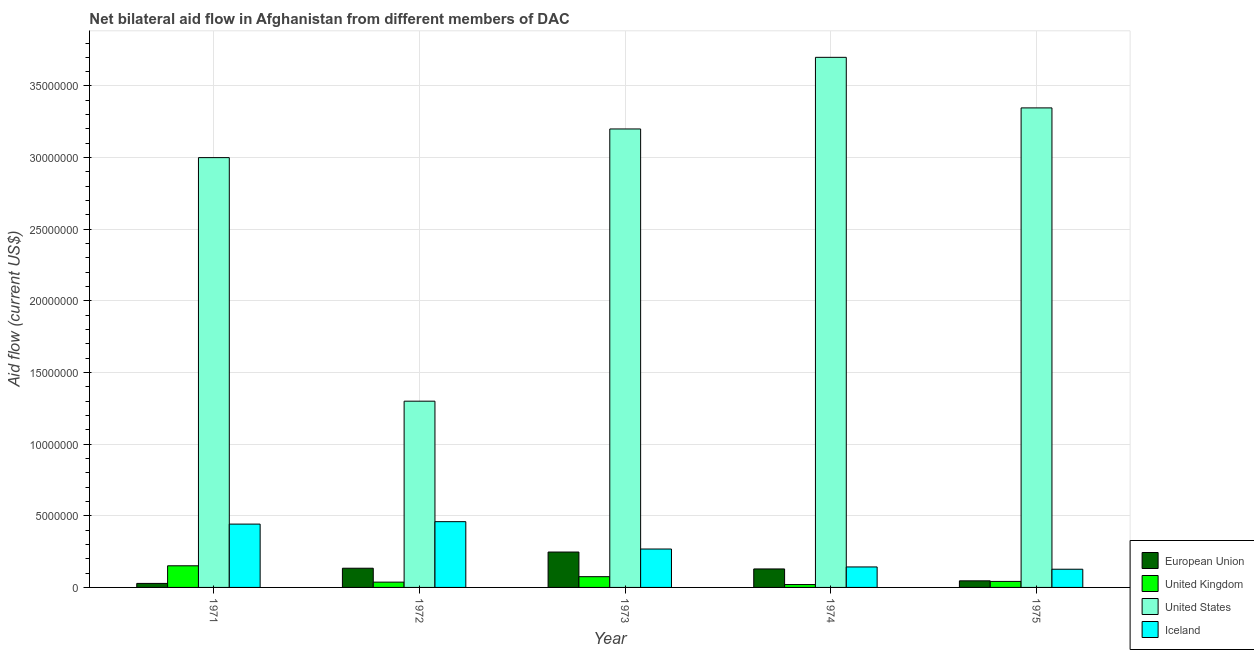How many different coloured bars are there?
Keep it short and to the point. 4. How many groups of bars are there?
Ensure brevity in your answer.  5. Are the number of bars per tick equal to the number of legend labels?
Your answer should be compact. Yes. How many bars are there on the 5th tick from the right?
Offer a very short reply. 4. What is the label of the 5th group of bars from the left?
Give a very brief answer. 1975. In how many cases, is the number of bars for a given year not equal to the number of legend labels?
Provide a short and direct response. 0. What is the amount of aid given by us in 1973?
Provide a succinct answer. 3.20e+07. Across all years, what is the maximum amount of aid given by us?
Your answer should be compact. 3.70e+07. Across all years, what is the minimum amount of aid given by iceland?
Offer a terse response. 1.27e+06. In which year was the amount of aid given by iceland maximum?
Provide a succinct answer. 1972. What is the total amount of aid given by us in the graph?
Provide a succinct answer. 1.45e+08. What is the difference between the amount of aid given by us in 1972 and that in 1975?
Your answer should be compact. -2.05e+07. What is the difference between the amount of aid given by uk in 1974 and the amount of aid given by eu in 1973?
Make the answer very short. -5.50e+05. What is the average amount of aid given by eu per year?
Offer a terse response. 1.17e+06. In the year 1974, what is the difference between the amount of aid given by uk and amount of aid given by eu?
Give a very brief answer. 0. What is the ratio of the amount of aid given by us in 1971 to that in 1975?
Your response must be concise. 0.9. Is the difference between the amount of aid given by us in 1971 and 1974 greater than the difference between the amount of aid given by iceland in 1971 and 1974?
Ensure brevity in your answer.  No. What is the difference between the highest and the second highest amount of aid given by eu?
Ensure brevity in your answer.  1.13e+06. What is the difference between the highest and the lowest amount of aid given by eu?
Make the answer very short. 2.19e+06. In how many years, is the amount of aid given by iceland greater than the average amount of aid given by iceland taken over all years?
Provide a succinct answer. 2. Is it the case that in every year, the sum of the amount of aid given by us and amount of aid given by uk is greater than the sum of amount of aid given by iceland and amount of aid given by eu?
Your answer should be compact. No. What does the 1st bar from the right in 1971 represents?
Ensure brevity in your answer.  Iceland. Is it the case that in every year, the sum of the amount of aid given by eu and amount of aid given by uk is greater than the amount of aid given by us?
Provide a succinct answer. No. How many bars are there?
Ensure brevity in your answer.  20. Are all the bars in the graph horizontal?
Provide a short and direct response. No. Are the values on the major ticks of Y-axis written in scientific E-notation?
Give a very brief answer. No. Does the graph contain any zero values?
Your answer should be very brief. No. Where does the legend appear in the graph?
Give a very brief answer. Bottom right. How many legend labels are there?
Make the answer very short. 4. What is the title of the graph?
Ensure brevity in your answer.  Net bilateral aid flow in Afghanistan from different members of DAC. Does "Subsidies and Transfers" appear as one of the legend labels in the graph?
Ensure brevity in your answer.  No. What is the label or title of the X-axis?
Keep it short and to the point. Year. What is the label or title of the Y-axis?
Give a very brief answer. Aid flow (current US$). What is the Aid flow (current US$) in European Union in 1971?
Your answer should be compact. 2.80e+05. What is the Aid flow (current US$) of United Kingdom in 1971?
Give a very brief answer. 1.51e+06. What is the Aid flow (current US$) of United States in 1971?
Keep it short and to the point. 3.00e+07. What is the Aid flow (current US$) of Iceland in 1971?
Provide a short and direct response. 4.42e+06. What is the Aid flow (current US$) of European Union in 1972?
Offer a terse response. 1.34e+06. What is the Aid flow (current US$) of United States in 1972?
Make the answer very short. 1.30e+07. What is the Aid flow (current US$) in Iceland in 1972?
Your answer should be compact. 4.59e+06. What is the Aid flow (current US$) of European Union in 1973?
Offer a terse response. 2.47e+06. What is the Aid flow (current US$) of United Kingdom in 1973?
Provide a succinct answer. 7.50e+05. What is the Aid flow (current US$) in United States in 1973?
Make the answer very short. 3.20e+07. What is the Aid flow (current US$) of Iceland in 1973?
Ensure brevity in your answer.  2.68e+06. What is the Aid flow (current US$) in European Union in 1974?
Provide a short and direct response. 1.29e+06. What is the Aid flow (current US$) in United States in 1974?
Provide a succinct answer. 3.70e+07. What is the Aid flow (current US$) in Iceland in 1974?
Your response must be concise. 1.43e+06. What is the Aid flow (current US$) of European Union in 1975?
Offer a very short reply. 4.60e+05. What is the Aid flow (current US$) in United States in 1975?
Your response must be concise. 3.35e+07. What is the Aid flow (current US$) in Iceland in 1975?
Make the answer very short. 1.27e+06. Across all years, what is the maximum Aid flow (current US$) in European Union?
Your response must be concise. 2.47e+06. Across all years, what is the maximum Aid flow (current US$) in United Kingdom?
Provide a short and direct response. 1.51e+06. Across all years, what is the maximum Aid flow (current US$) in United States?
Your answer should be very brief. 3.70e+07. Across all years, what is the maximum Aid flow (current US$) of Iceland?
Keep it short and to the point. 4.59e+06. Across all years, what is the minimum Aid flow (current US$) in United States?
Make the answer very short. 1.30e+07. Across all years, what is the minimum Aid flow (current US$) in Iceland?
Ensure brevity in your answer.  1.27e+06. What is the total Aid flow (current US$) of European Union in the graph?
Keep it short and to the point. 5.84e+06. What is the total Aid flow (current US$) in United Kingdom in the graph?
Offer a terse response. 3.25e+06. What is the total Aid flow (current US$) of United States in the graph?
Keep it short and to the point. 1.45e+08. What is the total Aid flow (current US$) of Iceland in the graph?
Make the answer very short. 1.44e+07. What is the difference between the Aid flow (current US$) in European Union in 1971 and that in 1972?
Your answer should be compact. -1.06e+06. What is the difference between the Aid flow (current US$) of United Kingdom in 1971 and that in 1972?
Offer a very short reply. 1.14e+06. What is the difference between the Aid flow (current US$) of United States in 1971 and that in 1972?
Ensure brevity in your answer.  1.70e+07. What is the difference between the Aid flow (current US$) in European Union in 1971 and that in 1973?
Your response must be concise. -2.19e+06. What is the difference between the Aid flow (current US$) in United Kingdom in 1971 and that in 1973?
Ensure brevity in your answer.  7.60e+05. What is the difference between the Aid flow (current US$) of Iceland in 1971 and that in 1973?
Offer a very short reply. 1.74e+06. What is the difference between the Aid flow (current US$) in European Union in 1971 and that in 1974?
Your answer should be very brief. -1.01e+06. What is the difference between the Aid flow (current US$) of United Kingdom in 1971 and that in 1974?
Your answer should be compact. 1.31e+06. What is the difference between the Aid flow (current US$) in United States in 1971 and that in 1974?
Offer a terse response. -7.00e+06. What is the difference between the Aid flow (current US$) in Iceland in 1971 and that in 1974?
Provide a succinct answer. 2.99e+06. What is the difference between the Aid flow (current US$) in European Union in 1971 and that in 1975?
Ensure brevity in your answer.  -1.80e+05. What is the difference between the Aid flow (current US$) in United Kingdom in 1971 and that in 1975?
Your response must be concise. 1.09e+06. What is the difference between the Aid flow (current US$) in United States in 1971 and that in 1975?
Your response must be concise. -3.47e+06. What is the difference between the Aid flow (current US$) of Iceland in 1971 and that in 1975?
Your answer should be very brief. 3.15e+06. What is the difference between the Aid flow (current US$) of European Union in 1972 and that in 1973?
Your answer should be very brief. -1.13e+06. What is the difference between the Aid flow (current US$) of United Kingdom in 1972 and that in 1973?
Provide a short and direct response. -3.80e+05. What is the difference between the Aid flow (current US$) of United States in 1972 and that in 1973?
Offer a very short reply. -1.90e+07. What is the difference between the Aid flow (current US$) in Iceland in 1972 and that in 1973?
Give a very brief answer. 1.91e+06. What is the difference between the Aid flow (current US$) in United States in 1972 and that in 1974?
Make the answer very short. -2.40e+07. What is the difference between the Aid flow (current US$) of Iceland in 1972 and that in 1974?
Ensure brevity in your answer.  3.16e+06. What is the difference between the Aid flow (current US$) of European Union in 1972 and that in 1975?
Your response must be concise. 8.80e+05. What is the difference between the Aid flow (current US$) in United States in 1972 and that in 1975?
Your answer should be compact. -2.05e+07. What is the difference between the Aid flow (current US$) in Iceland in 1972 and that in 1975?
Provide a succinct answer. 3.32e+06. What is the difference between the Aid flow (current US$) of European Union in 1973 and that in 1974?
Offer a terse response. 1.18e+06. What is the difference between the Aid flow (current US$) of United States in 1973 and that in 1974?
Ensure brevity in your answer.  -5.00e+06. What is the difference between the Aid flow (current US$) in Iceland in 1973 and that in 1974?
Your response must be concise. 1.25e+06. What is the difference between the Aid flow (current US$) in European Union in 1973 and that in 1975?
Your answer should be compact. 2.01e+06. What is the difference between the Aid flow (current US$) of United States in 1973 and that in 1975?
Your answer should be very brief. -1.47e+06. What is the difference between the Aid flow (current US$) of Iceland in 1973 and that in 1975?
Give a very brief answer. 1.41e+06. What is the difference between the Aid flow (current US$) in European Union in 1974 and that in 1975?
Keep it short and to the point. 8.30e+05. What is the difference between the Aid flow (current US$) in United States in 1974 and that in 1975?
Your answer should be compact. 3.53e+06. What is the difference between the Aid flow (current US$) of European Union in 1971 and the Aid flow (current US$) of United States in 1972?
Provide a short and direct response. -1.27e+07. What is the difference between the Aid flow (current US$) in European Union in 1971 and the Aid flow (current US$) in Iceland in 1972?
Your answer should be compact. -4.31e+06. What is the difference between the Aid flow (current US$) in United Kingdom in 1971 and the Aid flow (current US$) in United States in 1972?
Give a very brief answer. -1.15e+07. What is the difference between the Aid flow (current US$) of United Kingdom in 1971 and the Aid flow (current US$) of Iceland in 1972?
Offer a terse response. -3.08e+06. What is the difference between the Aid flow (current US$) in United States in 1971 and the Aid flow (current US$) in Iceland in 1972?
Offer a terse response. 2.54e+07. What is the difference between the Aid flow (current US$) of European Union in 1971 and the Aid flow (current US$) of United Kingdom in 1973?
Offer a very short reply. -4.70e+05. What is the difference between the Aid flow (current US$) in European Union in 1971 and the Aid flow (current US$) in United States in 1973?
Make the answer very short. -3.17e+07. What is the difference between the Aid flow (current US$) in European Union in 1971 and the Aid flow (current US$) in Iceland in 1973?
Ensure brevity in your answer.  -2.40e+06. What is the difference between the Aid flow (current US$) in United Kingdom in 1971 and the Aid flow (current US$) in United States in 1973?
Your answer should be very brief. -3.05e+07. What is the difference between the Aid flow (current US$) of United Kingdom in 1971 and the Aid flow (current US$) of Iceland in 1973?
Provide a short and direct response. -1.17e+06. What is the difference between the Aid flow (current US$) of United States in 1971 and the Aid flow (current US$) of Iceland in 1973?
Give a very brief answer. 2.73e+07. What is the difference between the Aid flow (current US$) in European Union in 1971 and the Aid flow (current US$) in United Kingdom in 1974?
Make the answer very short. 8.00e+04. What is the difference between the Aid flow (current US$) in European Union in 1971 and the Aid flow (current US$) in United States in 1974?
Your response must be concise. -3.67e+07. What is the difference between the Aid flow (current US$) in European Union in 1971 and the Aid flow (current US$) in Iceland in 1974?
Provide a succinct answer. -1.15e+06. What is the difference between the Aid flow (current US$) in United Kingdom in 1971 and the Aid flow (current US$) in United States in 1974?
Keep it short and to the point. -3.55e+07. What is the difference between the Aid flow (current US$) of United Kingdom in 1971 and the Aid flow (current US$) of Iceland in 1974?
Keep it short and to the point. 8.00e+04. What is the difference between the Aid flow (current US$) of United States in 1971 and the Aid flow (current US$) of Iceland in 1974?
Offer a very short reply. 2.86e+07. What is the difference between the Aid flow (current US$) of European Union in 1971 and the Aid flow (current US$) of United States in 1975?
Make the answer very short. -3.32e+07. What is the difference between the Aid flow (current US$) of European Union in 1971 and the Aid flow (current US$) of Iceland in 1975?
Offer a terse response. -9.90e+05. What is the difference between the Aid flow (current US$) of United Kingdom in 1971 and the Aid flow (current US$) of United States in 1975?
Ensure brevity in your answer.  -3.20e+07. What is the difference between the Aid flow (current US$) of United States in 1971 and the Aid flow (current US$) of Iceland in 1975?
Give a very brief answer. 2.87e+07. What is the difference between the Aid flow (current US$) of European Union in 1972 and the Aid flow (current US$) of United Kingdom in 1973?
Provide a succinct answer. 5.90e+05. What is the difference between the Aid flow (current US$) of European Union in 1972 and the Aid flow (current US$) of United States in 1973?
Your answer should be very brief. -3.07e+07. What is the difference between the Aid flow (current US$) of European Union in 1972 and the Aid flow (current US$) of Iceland in 1973?
Make the answer very short. -1.34e+06. What is the difference between the Aid flow (current US$) of United Kingdom in 1972 and the Aid flow (current US$) of United States in 1973?
Make the answer very short. -3.16e+07. What is the difference between the Aid flow (current US$) in United Kingdom in 1972 and the Aid flow (current US$) in Iceland in 1973?
Ensure brevity in your answer.  -2.31e+06. What is the difference between the Aid flow (current US$) of United States in 1972 and the Aid flow (current US$) of Iceland in 1973?
Your response must be concise. 1.03e+07. What is the difference between the Aid flow (current US$) in European Union in 1972 and the Aid flow (current US$) in United Kingdom in 1974?
Your response must be concise. 1.14e+06. What is the difference between the Aid flow (current US$) of European Union in 1972 and the Aid flow (current US$) of United States in 1974?
Ensure brevity in your answer.  -3.57e+07. What is the difference between the Aid flow (current US$) of European Union in 1972 and the Aid flow (current US$) of Iceland in 1974?
Provide a short and direct response. -9.00e+04. What is the difference between the Aid flow (current US$) of United Kingdom in 1972 and the Aid flow (current US$) of United States in 1974?
Ensure brevity in your answer.  -3.66e+07. What is the difference between the Aid flow (current US$) in United Kingdom in 1972 and the Aid flow (current US$) in Iceland in 1974?
Your answer should be compact. -1.06e+06. What is the difference between the Aid flow (current US$) in United States in 1972 and the Aid flow (current US$) in Iceland in 1974?
Provide a succinct answer. 1.16e+07. What is the difference between the Aid flow (current US$) of European Union in 1972 and the Aid flow (current US$) of United Kingdom in 1975?
Your answer should be very brief. 9.20e+05. What is the difference between the Aid flow (current US$) in European Union in 1972 and the Aid flow (current US$) in United States in 1975?
Offer a very short reply. -3.21e+07. What is the difference between the Aid flow (current US$) in European Union in 1972 and the Aid flow (current US$) in Iceland in 1975?
Provide a succinct answer. 7.00e+04. What is the difference between the Aid flow (current US$) of United Kingdom in 1972 and the Aid flow (current US$) of United States in 1975?
Provide a short and direct response. -3.31e+07. What is the difference between the Aid flow (current US$) of United Kingdom in 1972 and the Aid flow (current US$) of Iceland in 1975?
Make the answer very short. -9.00e+05. What is the difference between the Aid flow (current US$) of United States in 1972 and the Aid flow (current US$) of Iceland in 1975?
Make the answer very short. 1.17e+07. What is the difference between the Aid flow (current US$) of European Union in 1973 and the Aid flow (current US$) of United Kingdom in 1974?
Your answer should be very brief. 2.27e+06. What is the difference between the Aid flow (current US$) of European Union in 1973 and the Aid flow (current US$) of United States in 1974?
Your response must be concise. -3.45e+07. What is the difference between the Aid flow (current US$) of European Union in 1973 and the Aid flow (current US$) of Iceland in 1974?
Your response must be concise. 1.04e+06. What is the difference between the Aid flow (current US$) of United Kingdom in 1973 and the Aid flow (current US$) of United States in 1974?
Provide a short and direct response. -3.62e+07. What is the difference between the Aid flow (current US$) in United Kingdom in 1973 and the Aid flow (current US$) in Iceland in 1974?
Provide a short and direct response. -6.80e+05. What is the difference between the Aid flow (current US$) in United States in 1973 and the Aid flow (current US$) in Iceland in 1974?
Offer a very short reply. 3.06e+07. What is the difference between the Aid flow (current US$) of European Union in 1973 and the Aid flow (current US$) of United Kingdom in 1975?
Provide a short and direct response. 2.05e+06. What is the difference between the Aid flow (current US$) of European Union in 1973 and the Aid flow (current US$) of United States in 1975?
Make the answer very short. -3.10e+07. What is the difference between the Aid flow (current US$) of European Union in 1973 and the Aid flow (current US$) of Iceland in 1975?
Make the answer very short. 1.20e+06. What is the difference between the Aid flow (current US$) in United Kingdom in 1973 and the Aid flow (current US$) in United States in 1975?
Offer a terse response. -3.27e+07. What is the difference between the Aid flow (current US$) in United Kingdom in 1973 and the Aid flow (current US$) in Iceland in 1975?
Offer a terse response. -5.20e+05. What is the difference between the Aid flow (current US$) of United States in 1973 and the Aid flow (current US$) of Iceland in 1975?
Provide a succinct answer. 3.07e+07. What is the difference between the Aid flow (current US$) of European Union in 1974 and the Aid flow (current US$) of United Kingdom in 1975?
Provide a succinct answer. 8.70e+05. What is the difference between the Aid flow (current US$) in European Union in 1974 and the Aid flow (current US$) in United States in 1975?
Your response must be concise. -3.22e+07. What is the difference between the Aid flow (current US$) in European Union in 1974 and the Aid flow (current US$) in Iceland in 1975?
Make the answer very short. 2.00e+04. What is the difference between the Aid flow (current US$) in United Kingdom in 1974 and the Aid flow (current US$) in United States in 1975?
Keep it short and to the point. -3.33e+07. What is the difference between the Aid flow (current US$) of United Kingdom in 1974 and the Aid flow (current US$) of Iceland in 1975?
Keep it short and to the point. -1.07e+06. What is the difference between the Aid flow (current US$) of United States in 1974 and the Aid flow (current US$) of Iceland in 1975?
Your answer should be compact. 3.57e+07. What is the average Aid flow (current US$) in European Union per year?
Your response must be concise. 1.17e+06. What is the average Aid flow (current US$) in United Kingdom per year?
Your response must be concise. 6.50e+05. What is the average Aid flow (current US$) in United States per year?
Offer a terse response. 2.91e+07. What is the average Aid flow (current US$) of Iceland per year?
Give a very brief answer. 2.88e+06. In the year 1971, what is the difference between the Aid flow (current US$) of European Union and Aid flow (current US$) of United Kingdom?
Make the answer very short. -1.23e+06. In the year 1971, what is the difference between the Aid flow (current US$) of European Union and Aid flow (current US$) of United States?
Offer a terse response. -2.97e+07. In the year 1971, what is the difference between the Aid flow (current US$) in European Union and Aid flow (current US$) in Iceland?
Offer a terse response. -4.14e+06. In the year 1971, what is the difference between the Aid flow (current US$) of United Kingdom and Aid flow (current US$) of United States?
Offer a very short reply. -2.85e+07. In the year 1971, what is the difference between the Aid flow (current US$) in United Kingdom and Aid flow (current US$) in Iceland?
Your answer should be compact. -2.91e+06. In the year 1971, what is the difference between the Aid flow (current US$) in United States and Aid flow (current US$) in Iceland?
Your response must be concise. 2.56e+07. In the year 1972, what is the difference between the Aid flow (current US$) of European Union and Aid flow (current US$) of United Kingdom?
Offer a very short reply. 9.70e+05. In the year 1972, what is the difference between the Aid flow (current US$) of European Union and Aid flow (current US$) of United States?
Your answer should be compact. -1.17e+07. In the year 1972, what is the difference between the Aid flow (current US$) of European Union and Aid flow (current US$) of Iceland?
Your answer should be compact. -3.25e+06. In the year 1972, what is the difference between the Aid flow (current US$) in United Kingdom and Aid flow (current US$) in United States?
Provide a succinct answer. -1.26e+07. In the year 1972, what is the difference between the Aid flow (current US$) of United Kingdom and Aid flow (current US$) of Iceland?
Provide a succinct answer. -4.22e+06. In the year 1972, what is the difference between the Aid flow (current US$) of United States and Aid flow (current US$) of Iceland?
Keep it short and to the point. 8.41e+06. In the year 1973, what is the difference between the Aid flow (current US$) of European Union and Aid flow (current US$) of United Kingdom?
Your answer should be very brief. 1.72e+06. In the year 1973, what is the difference between the Aid flow (current US$) of European Union and Aid flow (current US$) of United States?
Provide a succinct answer. -2.95e+07. In the year 1973, what is the difference between the Aid flow (current US$) of European Union and Aid flow (current US$) of Iceland?
Give a very brief answer. -2.10e+05. In the year 1973, what is the difference between the Aid flow (current US$) of United Kingdom and Aid flow (current US$) of United States?
Offer a terse response. -3.12e+07. In the year 1973, what is the difference between the Aid flow (current US$) of United Kingdom and Aid flow (current US$) of Iceland?
Ensure brevity in your answer.  -1.93e+06. In the year 1973, what is the difference between the Aid flow (current US$) in United States and Aid flow (current US$) in Iceland?
Make the answer very short. 2.93e+07. In the year 1974, what is the difference between the Aid flow (current US$) of European Union and Aid flow (current US$) of United Kingdom?
Provide a succinct answer. 1.09e+06. In the year 1974, what is the difference between the Aid flow (current US$) of European Union and Aid flow (current US$) of United States?
Ensure brevity in your answer.  -3.57e+07. In the year 1974, what is the difference between the Aid flow (current US$) of United Kingdom and Aid flow (current US$) of United States?
Keep it short and to the point. -3.68e+07. In the year 1974, what is the difference between the Aid flow (current US$) of United Kingdom and Aid flow (current US$) of Iceland?
Make the answer very short. -1.23e+06. In the year 1974, what is the difference between the Aid flow (current US$) of United States and Aid flow (current US$) of Iceland?
Offer a very short reply. 3.56e+07. In the year 1975, what is the difference between the Aid flow (current US$) of European Union and Aid flow (current US$) of United Kingdom?
Your answer should be compact. 4.00e+04. In the year 1975, what is the difference between the Aid flow (current US$) of European Union and Aid flow (current US$) of United States?
Give a very brief answer. -3.30e+07. In the year 1975, what is the difference between the Aid flow (current US$) in European Union and Aid flow (current US$) in Iceland?
Provide a succinct answer. -8.10e+05. In the year 1975, what is the difference between the Aid flow (current US$) in United Kingdom and Aid flow (current US$) in United States?
Provide a succinct answer. -3.30e+07. In the year 1975, what is the difference between the Aid flow (current US$) in United Kingdom and Aid flow (current US$) in Iceland?
Provide a succinct answer. -8.50e+05. In the year 1975, what is the difference between the Aid flow (current US$) of United States and Aid flow (current US$) of Iceland?
Provide a short and direct response. 3.22e+07. What is the ratio of the Aid flow (current US$) of European Union in 1971 to that in 1972?
Your answer should be very brief. 0.21. What is the ratio of the Aid flow (current US$) of United Kingdom in 1971 to that in 1972?
Your answer should be very brief. 4.08. What is the ratio of the Aid flow (current US$) in United States in 1971 to that in 1972?
Give a very brief answer. 2.31. What is the ratio of the Aid flow (current US$) of Iceland in 1971 to that in 1972?
Make the answer very short. 0.96. What is the ratio of the Aid flow (current US$) of European Union in 1971 to that in 1973?
Offer a terse response. 0.11. What is the ratio of the Aid flow (current US$) in United Kingdom in 1971 to that in 1973?
Keep it short and to the point. 2.01. What is the ratio of the Aid flow (current US$) of Iceland in 1971 to that in 1973?
Offer a very short reply. 1.65. What is the ratio of the Aid flow (current US$) in European Union in 1971 to that in 1974?
Your answer should be compact. 0.22. What is the ratio of the Aid flow (current US$) in United Kingdom in 1971 to that in 1974?
Provide a succinct answer. 7.55. What is the ratio of the Aid flow (current US$) in United States in 1971 to that in 1974?
Keep it short and to the point. 0.81. What is the ratio of the Aid flow (current US$) in Iceland in 1971 to that in 1974?
Provide a succinct answer. 3.09. What is the ratio of the Aid flow (current US$) of European Union in 1971 to that in 1975?
Offer a terse response. 0.61. What is the ratio of the Aid flow (current US$) of United Kingdom in 1971 to that in 1975?
Your answer should be compact. 3.6. What is the ratio of the Aid flow (current US$) of United States in 1971 to that in 1975?
Offer a very short reply. 0.9. What is the ratio of the Aid flow (current US$) in Iceland in 1971 to that in 1975?
Your answer should be very brief. 3.48. What is the ratio of the Aid flow (current US$) of European Union in 1972 to that in 1973?
Provide a short and direct response. 0.54. What is the ratio of the Aid flow (current US$) in United Kingdom in 1972 to that in 1973?
Ensure brevity in your answer.  0.49. What is the ratio of the Aid flow (current US$) in United States in 1972 to that in 1973?
Your response must be concise. 0.41. What is the ratio of the Aid flow (current US$) of Iceland in 1972 to that in 1973?
Your response must be concise. 1.71. What is the ratio of the Aid flow (current US$) in European Union in 1972 to that in 1974?
Ensure brevity in your answer.  1.04. What is the ratio of the Aid flow (current US$) of United Kingdom in 1972 to that in 1974?
Keep it short and to the point. 1.85. What is the ratio of the Aid flow (current US$) of United States in 1972 to that in 1974?
Give a very brief answer. 0.35. What is the ratio of the Aid flow (current US$) of Iceland in 1972 to that in 1974?
Your answer should be compact. 3.21. What is the ratio of the Aid flow (current US$) in European Union in 1972 to that in 1975?
Provide a short and direct response. 2.91. What is the ratio of the Aid flow (current US$) in United Kingdom in 1972 to that in 1975?
Keep it short and to the point. 0.88. What is the ratio of the Aid flow (current US$) in United States in 1972 to that in 1975?
Your response must be concise. 0.39. What is the ratio of the Aid flow (current US$) of Iceland in 1972 to that in 1975?
Make the answer very short. 3.61. What is the ratio of the Aid flow (current US$) of European Union in 1973 to that in 1974?
Offer a terse response. 1.91. What is the ratio of the Aid flow (current US$) in United Kingdom in 1973 to that in 1974?
Provide a short and direct response. 3.75. What is the ratio of the Aid flow (current US$) of United States in 1973 to that in 1974?
Ensure brevity in your answer.  0.86. What is the ratio of the Aid flow (current US$) of Iceland in 1973 to that in 1974?
Provide a succinct answer. 1.87. What is the ratio of the Aid flow (current US$) of European Union in 1973 to that in 1975?
Ensure brevity in your answer.  5.37. What is the ratio of the Aid flow (current US$) in United Kingdom in 1973 to that in 1975?
Make the answer very short. 1.79. What is the ratio of the Aid flow (current US$) in United States in 1973 to that in 1975?
Keep it short and to the point. 0.96. What is the ratio of the Aid flow (current US$) in Iceland in 1973 to that in 1975?
Offer a terse response. 2.11. What is the ratio of the Aid flow (current US$) of European Union in 1974 to that in 1975?
Offer a terse response. 2.8. What is the ratio of the Aid flow (current US$) of United Kingdom in 1974 to that in 1975?
Keep it short and to the point. 0.48. What is the ratio of the Aid flow (current US$) in United States in 1974 to that in 1975?
Make the answer very short. 1.11. What is the ratio of the Aid flow (current US$) of Iceland in 1974 to that in 1975?
Offer a very short reply. 1.13. What is the difference between the highest and the second highest Aid flow (current US$) in European Union?
Offer a terse response. 1.13e+06. What is the difference between the highest and the second highest Aid flow (current US$) of United Kingdom?
Give a very brief answer. 7.60e+05. What is the difference between the highest and the second highest Aid flow (current US$) of United States?
Your answer should be very brief. 3.53e+06. What is the difference between the highest and the second highest Aid flow (current US$) in Iceland?
Give a very brief answer. 1.70e+05. What is the difference between the highest and the lowest Aid flow (current US$) of European Union?
Give a very brief answer. 2.19e+06. What is the difference between the highest and the lowest Aid flow (current US$) in United Kingdom?
Make the answer very short. 1.31e+06. What is the difference between the highest and the lowest Aid flow (current US$) in United States?
Your response must be concise. 2.40e+07. What is the difference between the highest and the lowest Aid flow (current US$) in Iceland?
Make the answer very short. 3.32e+06. 